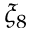Convert formula to latex. <formula><loc_0><loc_0><loc_500><loc_500>\xi _ { 8 }</formula> 